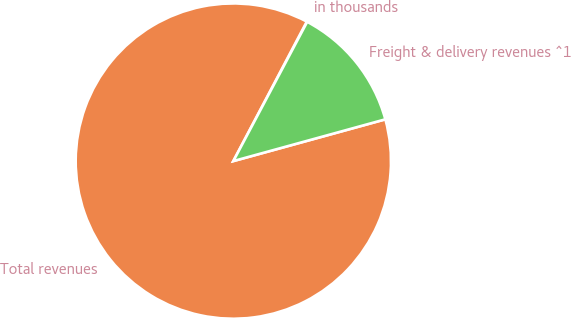<chart> <loc_0><loc_0><loc_500><loc_500><pie_chart><fcel>in thousands<fcel>Total revenues<fcel>Freight & delivery revenues ^1<nl><fcel>0.05%<fcel>86.98%<fcel>12.97%<nl></chart> 